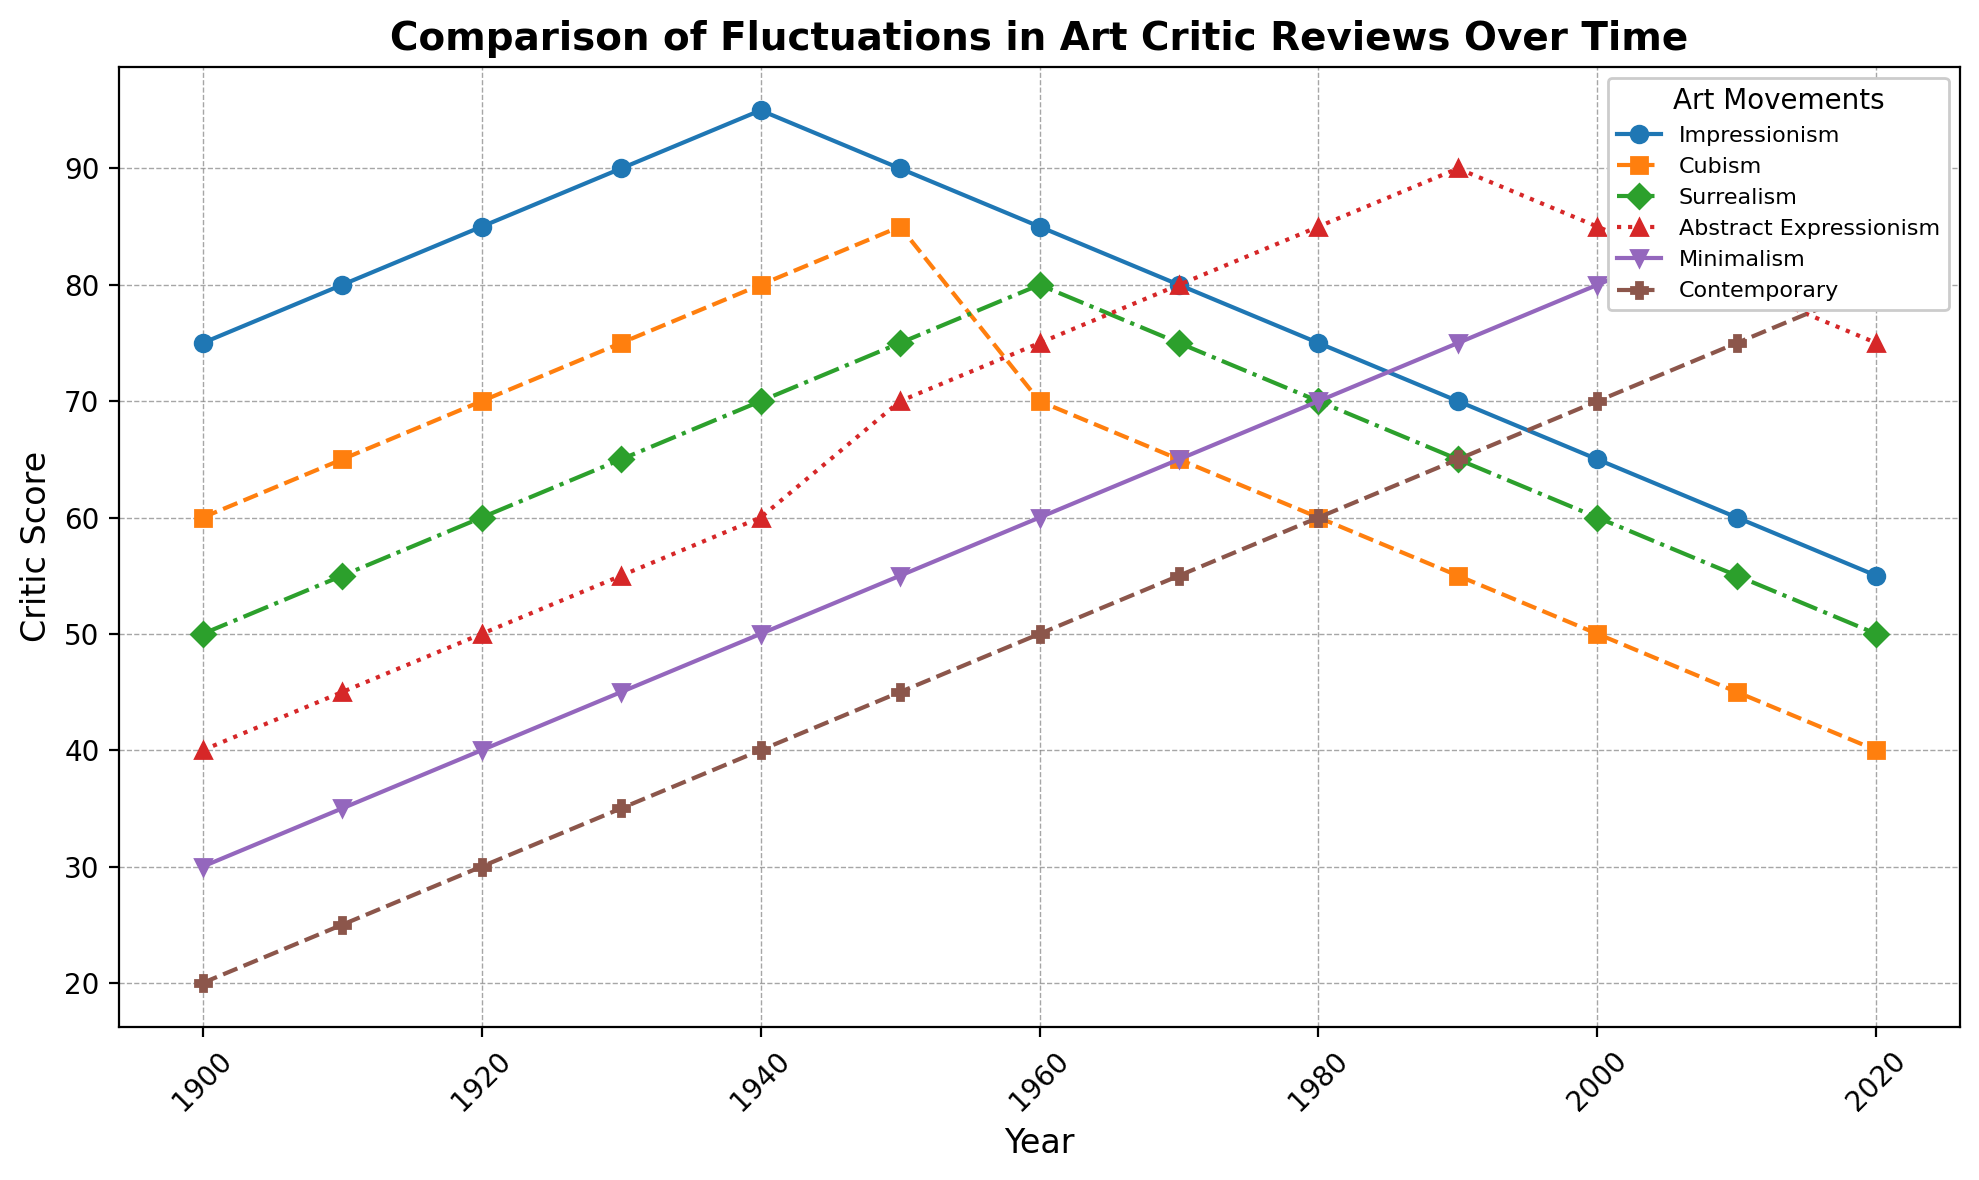Which art movement has shown the most significant growth in critic scores from 1900 to 2020? To determine this, we look at the critic scores for each art movement in 1900 and 2020 and find the difference. Impressionism: 75->55 (-20), Cubism: 60->40 (-20), Surrealism: 50->50 (0), Abstract Expressionism: 40->75 (+35), Minimalism: 30->90 (+60), Contemporary: 20->80 (+60). Minimalism and Contemporary show an increase of 60 points each.
Answer: Minimalism and Contemporary In which decades did Abstract Expressionism receive the highest critic scores compared to other movements? We examine the plot for the peaks in Abstract Expressionism and compare them with the critic scores of other art movements in those years. The highest scores are in 1980, 1990, 2000, and 2010.
Answer: 1990, 2000, 2010 Which art movement had a steady increase in critic scores from 1900 to 1950 but declined afterward? By observing the trends, Minimalism steadily increased from 1900 (30) to 1950 (55) but declined afterward.
Answer: Minimalism What is the average critic score for Cubism during the 20th century? The average for Cubism from 1900 to 2000 is calculated by summing the scores and dividing by the number of years: (60+65+70+75+80+85+70+65+60+55+50)/11 ≈ 66.36.
Answer: 66.36 Which two art movements had equal critic scores in the year 1910? Referring to the plot, Minimalism and Contemporary both have critic scores of 25 in 1910.
Answer: Minimalism, Contemporary Between 1960 and 2020, which decade shows the maximum fluctuations in Contemporary art movement scores? Observing the plot for Contemporary scores, we find variations per decade. 1960-50, 1970-55, 1980-60, 1990-65, 2000-70, 2010-75, 2020-80. The fluctuations are consistent, but the highest is between 1990 and 2000 with 5 points.
Answer: 1990-2000 In which decade did Impressionism receive its lowest critic score, and what was the score? From the plot, Impressionism has its lowest score of 55 in 2020.
Answer: 2020, 55 Which art movement had a higher score in 1950: Surrealism or Cubism? Checking the plot, Surrealism has 75 and Cubism has 85 in 1950. Therefore, Cubism had a higher score.
Answer: Cubism Throughout the entire timeframe, which art movement consistently had the lowest critic scores? By observing the plot, Minimalism consistently starts with the lowest scores except for the later years where Contemporary starts lower initially. However, Minimalism is generally the lowest.
Answer: Minimalism 